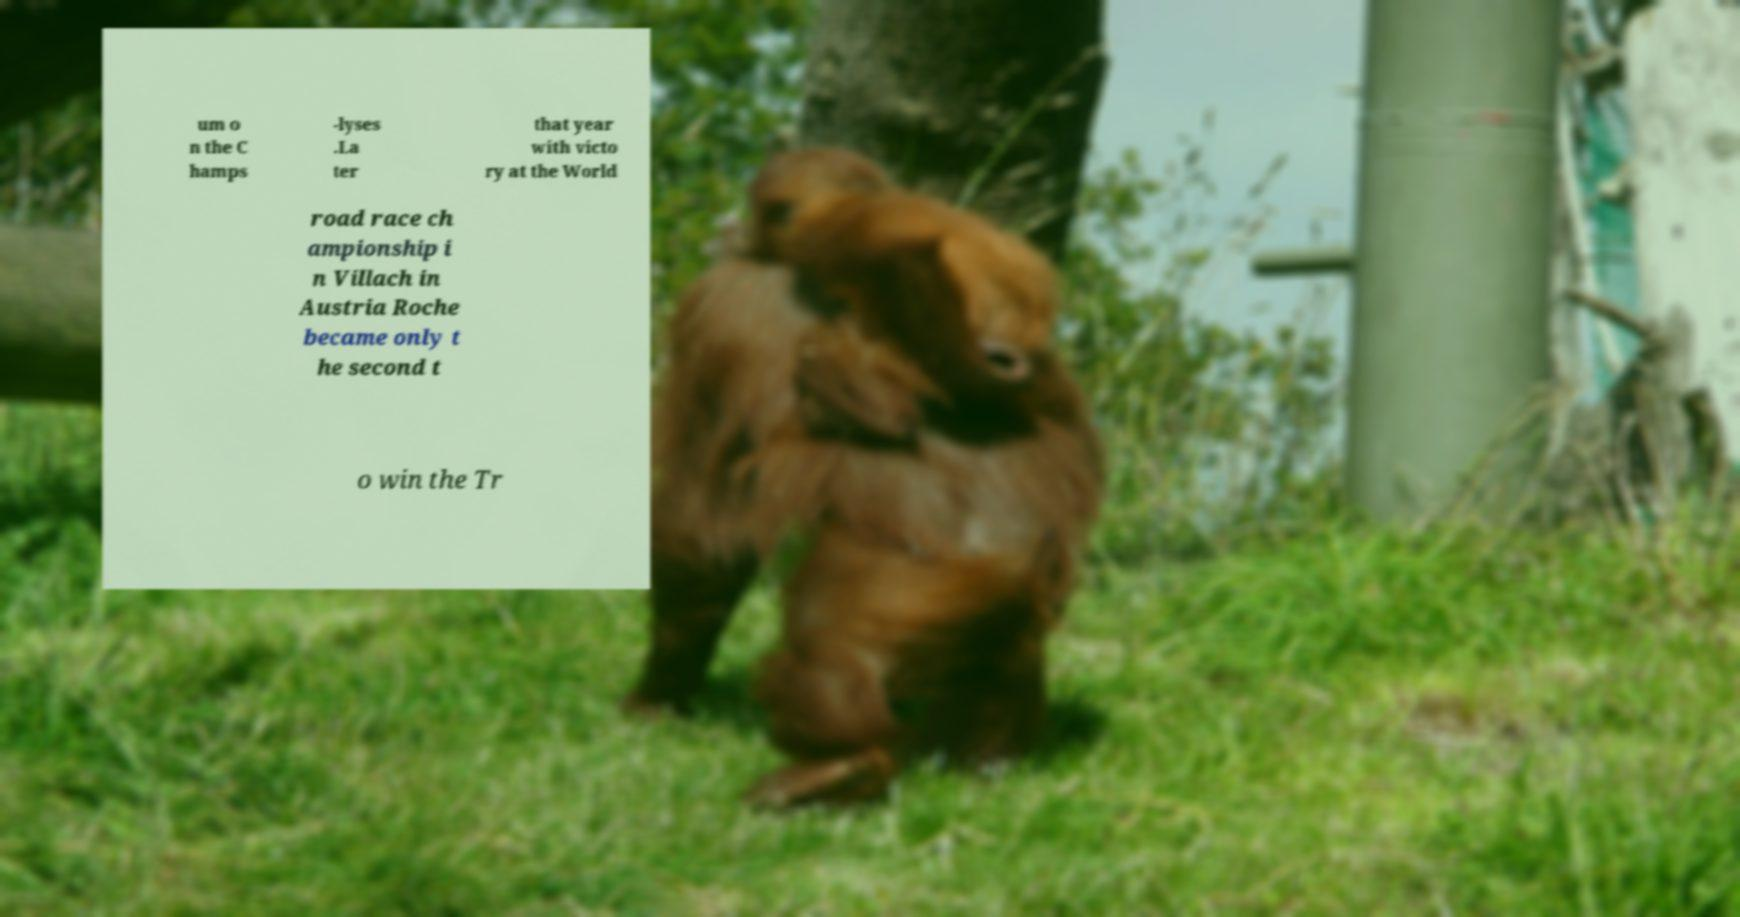Please identify and transcribe the text found in this image. um o n the C hamps -lyses .La ter that year with victo ry at the World road race ch ampionship i n Villach in Austria Roche became only t he second t o win the Tr 